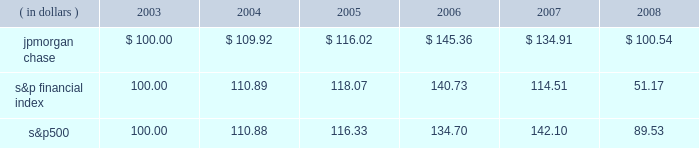Management 2019s discussion and analysis jpmorgan chase & co .
/ 2008 annual report 39 five-year stock performance the table and graph compare the five-year cumulative total return for jpmorgan chase & co .
( 201cjpmorgan chase 201d or the 201cfirm 201d ) common stock with the cumulative return of the s&p 500 stock index and the s&p financial index .
The s&p 500 index is a commonly referenced u.s .
Equity benchmark consisting of leading companies from different economic sectors .
The s&p financial index is an index of 81 financial companies , all of which are within the s&p 500 .
The firm is a component of both industry indices .
The table and graph assumes simultaneous investments of $ 100 on december 31 , 2003 , in jpmorgan chase common stock and in each of the above s&p indices .
The comparison assumes that all dividends are reinvested .
This section of the jpmorgan chase 2019s annual report for the year ended december 31 , 2008 ( 201cannual report 201d ) provides manage- ment 2019s discussion and analysis of the financial condition and results of operations ( 201cmd&a 201d ) of jpmorgan chase .
See the glossary of terms on pages 230 2013233 for definitions of terms used throughout this annual report .
The md&a included in this annual report con- tains statements that are forward-looking within the meaning of the private securities litigation reform act of 1995 .
Such statements are based upon the current beliefs and expectations of jpmorgan december 31 .
December 31 , ( in dollars ) 2003 2004 2005 2006 2007 2008 s&p financial s&p 500jpmorgan chase chase 2019s management and are subject to significant risks and uncer- tainties .
These risks and uncertainties could cause jpmorgan chase 2019s results to differ materially from those set forth in such forward-look- ing statements .
Certain of such risks and uncertainties are described herein ( see forward-looking statements on page 127 of this annual report ) and in the jpmorgan chase annual report on form 10-k for the year ended december 31 , 2008 ( 201c2008 form 10-k 201d ) , in part i , item 1a : risk factors , to which reference is hereby made .
Introduction jpmorgan chase & co. , a financial holding company incorporated under delaware law in 1968 , is a leading global financial services firm and one of the largest banking institutions in the united states of america ( 201cu.s . 201d ) , with $ 2.2 trillion in assets , $ 166.9 billion in stockholders 2019 equity and operations in more than 60 countries as of december 31 , 2008 .
The firm is a leader in investment banking , financial services for consumers and businesses , financial transaction processing and asset management .
Under the j.p .
Morgan and chase brands , the firm serves millions of customers in the u.s .
And many of the world 2019s most prominent corporate , institutional and government clients .
Jpmorgan chase 2019s principal bank subsidiaries are jpmorgan chase bank , national association ( 201cjpmorgan chase bank , n.a . 201d ) , a nation- al banking association with branches in 23 states in the u.s. ; and chase bank usa , national association ( 201cchase bank usa , n.a . 201d ) , a national bank that is the firm 2019s credit card issuing bank .
Jpmorgan chase 2019s principal nonbank subsidiary is j.p .
Morgan securities inc. , the firm 2019s u.s .
Investment banking firm .
Jpmorgan chase 2019s activities are organized , for management reporting purposes , into six business segments , as well as corporate/private equity .
The firm 2019s wholesale businesses comprise the investment bank , commercial banking , treasury & securities services and asset management segments .
The firm 2019s consumer businesses comprise the retail financial services and card services segments .
A description of the firm 2019s business segments , and the products and services they pro- vide to their respective client bases , follows .
Investment bank j.p .
Morgan is one of the world 2019s leading investment banks , with deep client relationships and broad product capabilities .
The investment bank 2019s clients are corporations , financial institutions , governments and institutional investors .
The firm offers a full range of investment banking products and services in all major capital markets , including advising on corporate strategy and structure , cap- ital raising in equity and debt markets , sophisticated risk manage- ment , market-making in cash securities and derivative instruments , prime brokerage and research .
The investment bank ( 201cib 201d ) also selectively commits the firm 2019s own capital to principal investing and trading activities .
Retail financial services retail financial services ( 201crfs 201d ) , which includes the retail banking and consumer lending reporting segments , serves consumers and businesses through personal service at bank branches and through atms , online banking and telephone banking as well as through auto dealerships and school financial aid offices .
Customers can use more than 5400 bank branches ( third-largest nationally ) and 14500 atms ( second-largest nationally ) as well as online and mobile bank- ing around the clock .
More than 21400 branch salespeople assist .
On a four year basis , did jpmorgan chase outperform the s&p financial index? 
Computations: (134.91 > 114.51)
Answer: yes. 